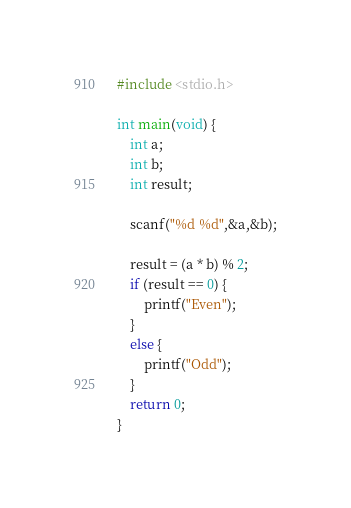Convert code to text. <code><loc_0><loc_0><loc_500><loc_500><_C_>#include <stdio.h>
 
int main(void) {
    int a;
    int b;
    int result;

    scanf("%d %d",&a,&b);

    result = (a * b) % 2;
    if (result == 0) {
        printf("Even");
    }
    else {
        printf("Odd");
    }
    return 0;
}</code> 